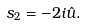<formula> <loc_0><loc_0><loc_500><loc_500>s _ { 2 } = - 2 i \hat { u } .</formula> 